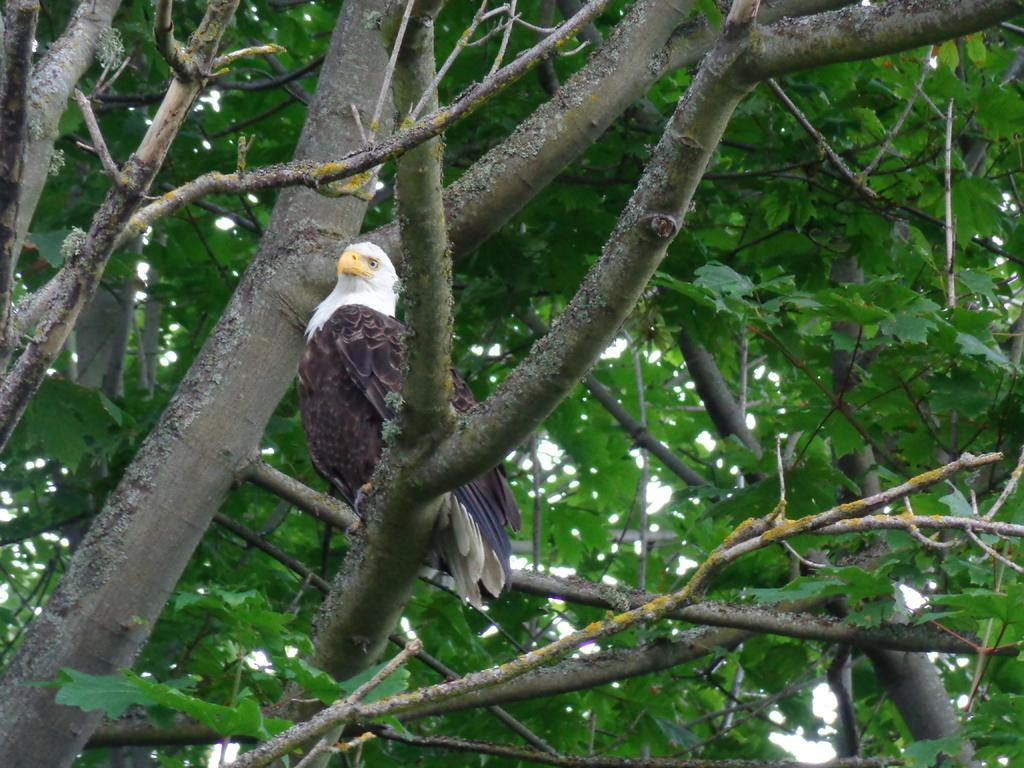What type of animal can be seen in the image? There is a bird in the image. Where is the bird located? The bird is standing on a branch of a tree. What part of the natural environment is visible in the image? The sky is visible in the image. What type of sweater is the bird wearing in the image? There is no sweater present in the image, as birds do not wear clothing. 